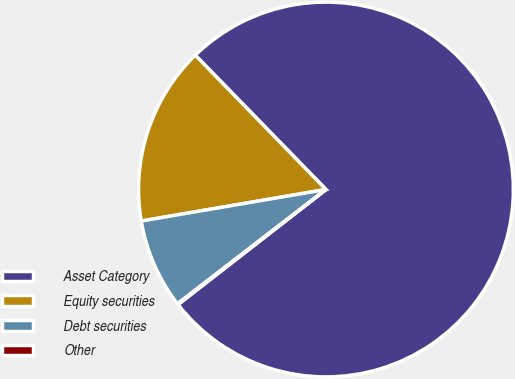Convert chart to OTSL. <chart><loc_0><loc_0><loc_500><loc_500><pie_chart><fcel>Asset Category<fcel>Equity securities<fcel>Debt securities<fcel>Other<nl><fcel>76.76%<fcel>15.41%<fcel>7.75%<fcel>0.08%<nl></chart> 